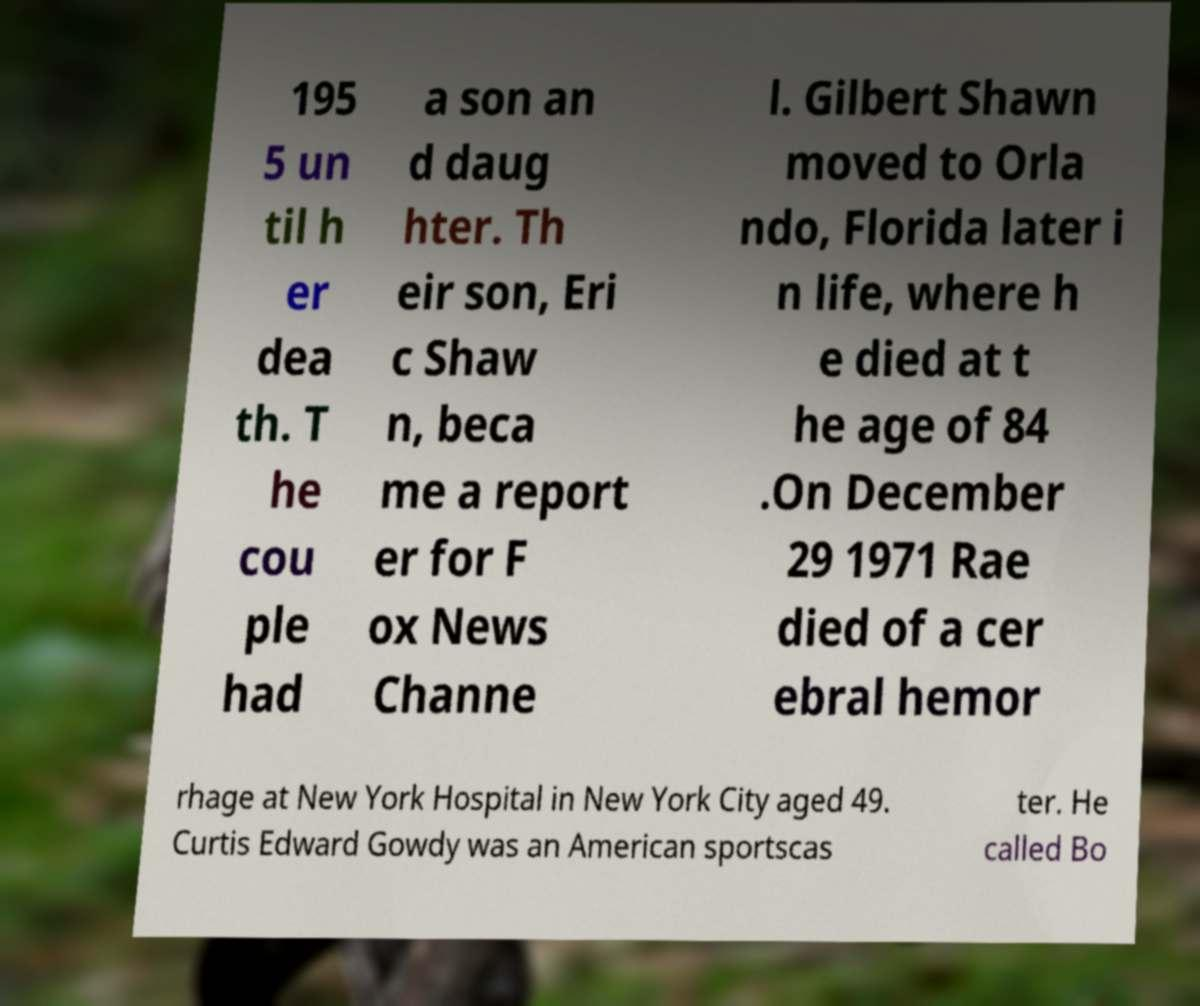Could you assist in decoding the text presented in this image and type it out clearly? 195 5 un til h er dea th. T he cou ple had a son an d daug hter. Th eir son, Eri c Shaw n, beca me a report er for F ox News Channe l. Gilbert Shawn moved to Orla ndo, Florida later i n life, where h e died at t he age of 84 .On December 29 1971 Rae died of a cer ebral hemor rhage at New York Hospital in New York City aged 49. Curtis Edward Gowdy was an American sportscas ter. He called Bo 